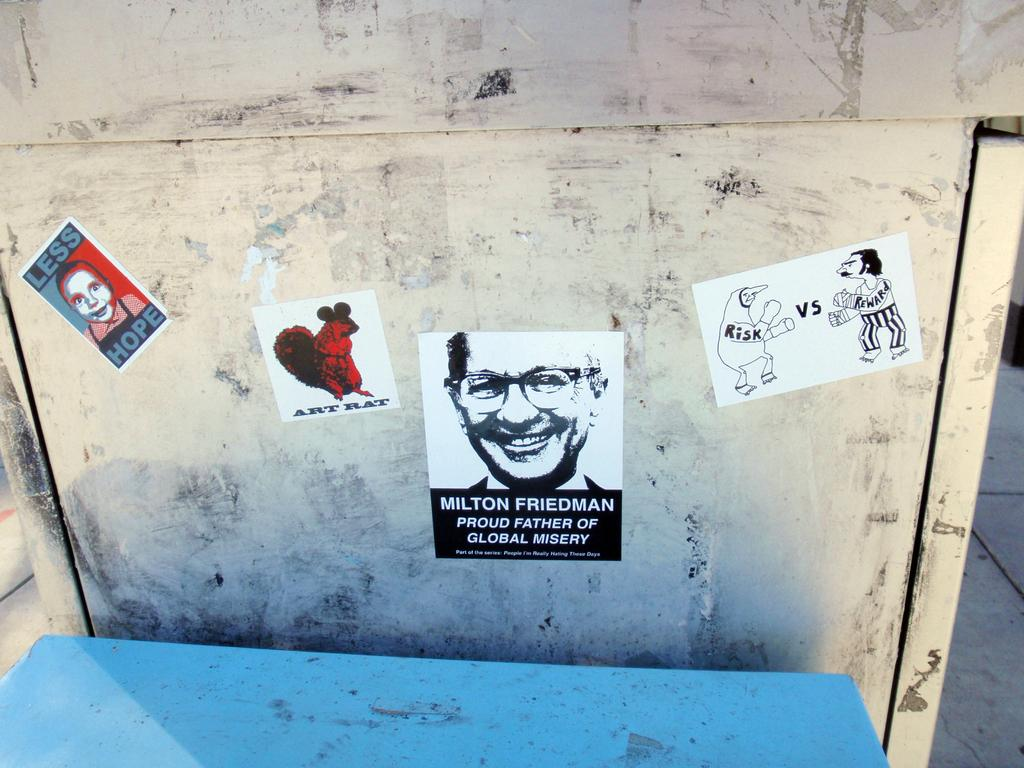What can be seen on the surface in the image? There are posters in the image. How are the posters attached to the surface? The posters are attached to a surface. What is located in front of the posters? There is a blue object in front of the posters. Is the room in the image quiet or noisy? The provided facts do not mention anything about the room or its noise level, so it cannot be determined from the image. 